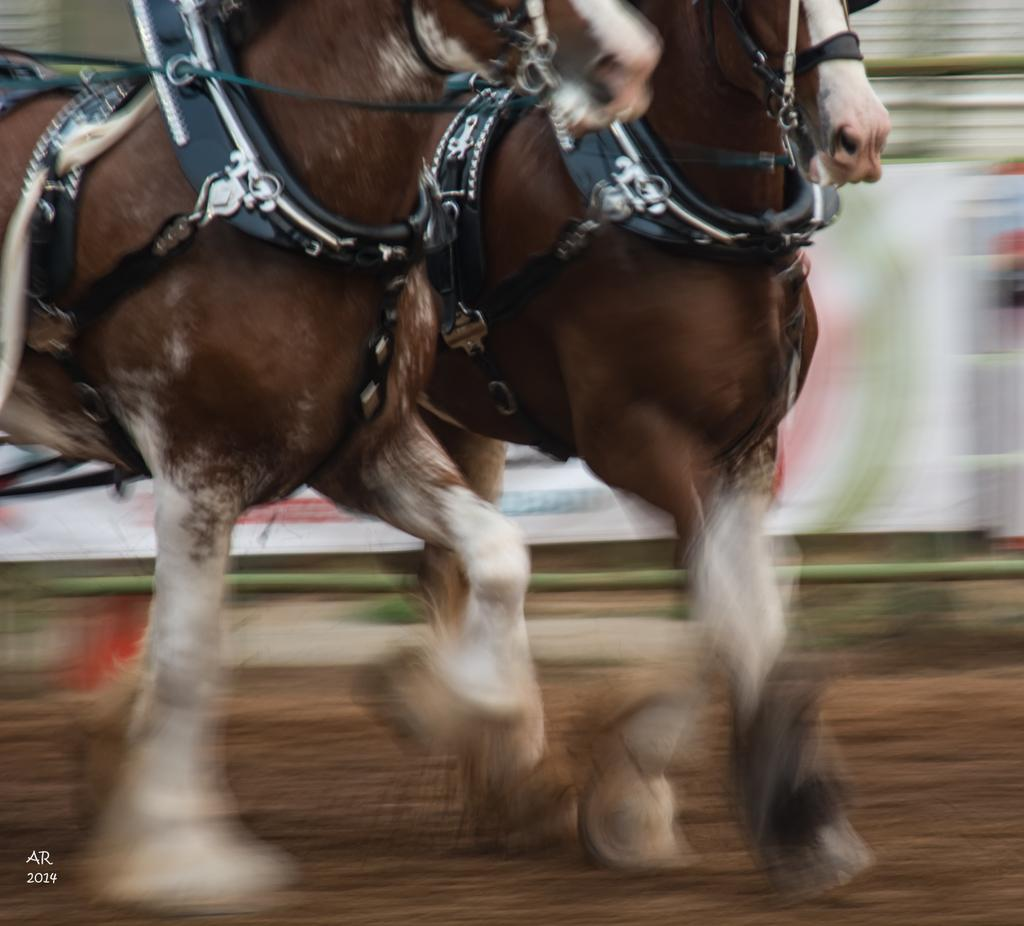What animals can be seen in the foreground of the image? There are two horses in the foreground of the image. What are the horses doing in the image? The horses are running on the ground. Can you describe the background of the image? The background of the image is blurred. How many tomatoes are being held by the horses in the image? There are no tomatoes present in the image; the horses are running on the ground. What message of hope can be seen in the image? There is no message of hope depicted in the image; it features two horses running on the ground. 